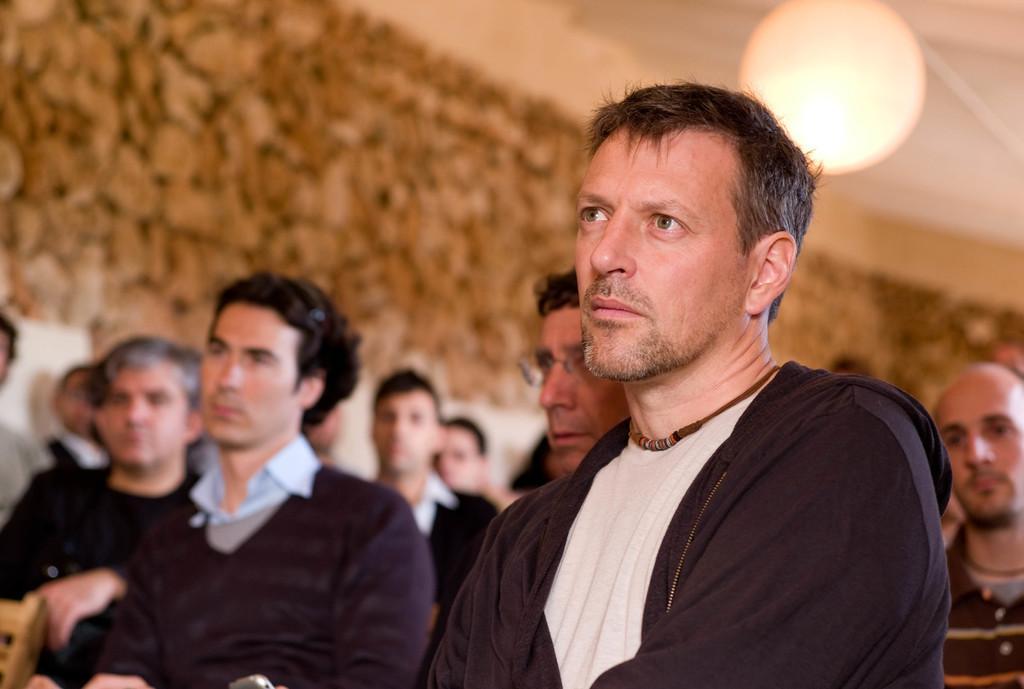In one or two sentences, can you explain what this image depicts? In this image I can see the group of people with different color dresses. In the top I can see the light. And there is a blurred background. 